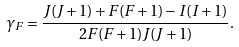<formula> <loc_0><loc_0><loc_500><loc_500>\gamma _ { F } = \frac { J ( J + 1 ) + F ( F + 1 ) - I ( I + 1 ) } { 2 F ( F + 1 ) J ( J + 1 ) } .</formula> 